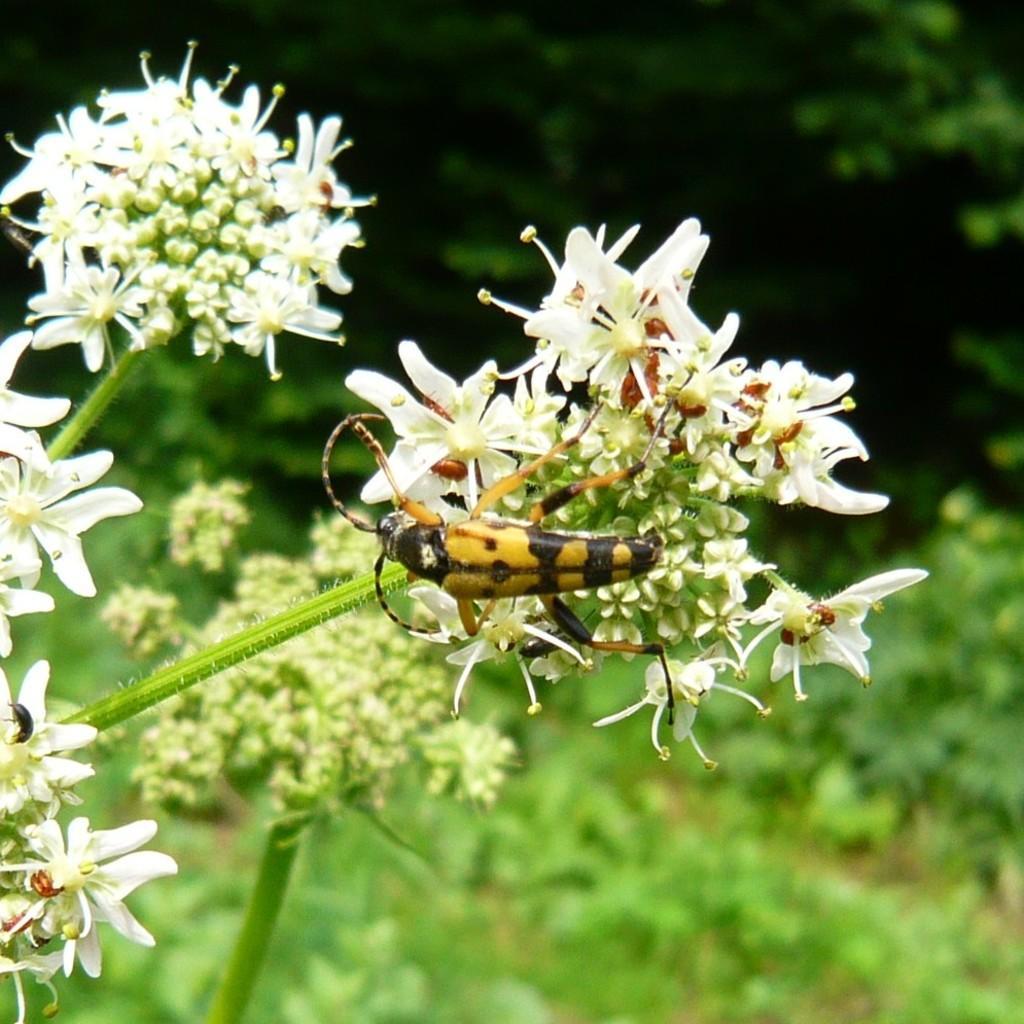How would you summarize this image in a sentence or two? In this image we can see greenery on the back side and on the frontside we can see the white color flower with stem and a bug standing on the flower. 